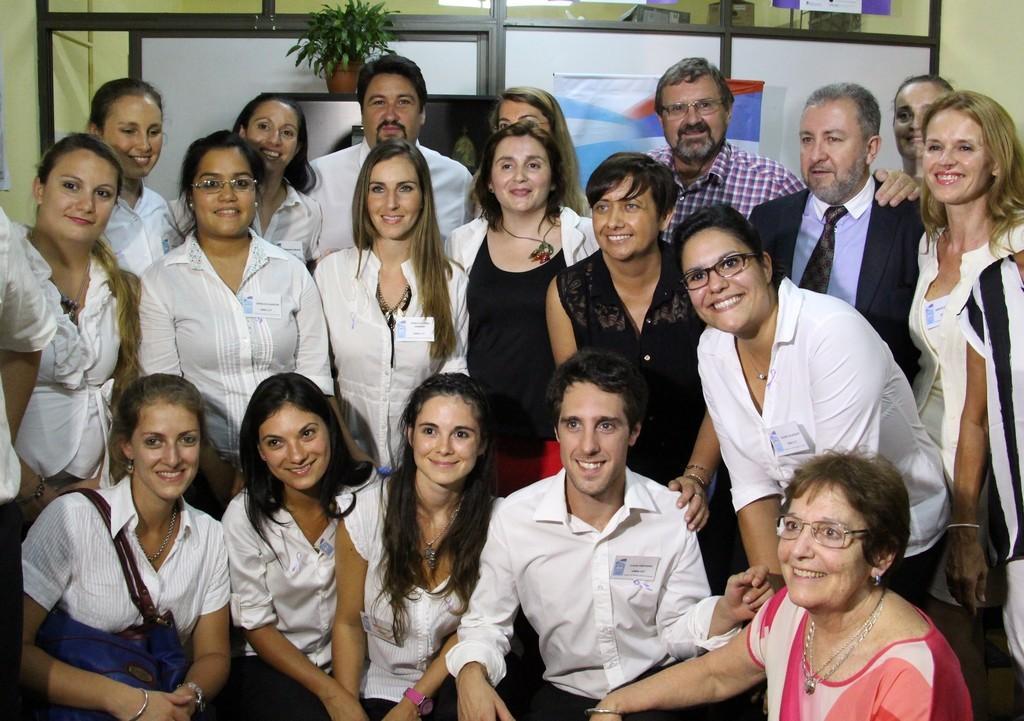Could you give a brief overview of what you see in this image? At the bottom we can see few persons in squat position and behind them there are few persons standing. In the background we can see wall,door,house plant on an object,hoardings and other objects. 